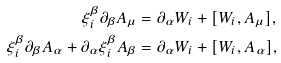Convert formula to latex. <formula><loc_0><loc_0><loc_500><loc_500>\xi _ { i } ^ { \beta } \partial _ { \beta } A _ { \mu } & = \partial _ { \alpha } W _ { i } + [ W _ { i } , A _ { \mu } ] , \\ \xi _ { i } ^ { \beta } \partial _ { \beta } A _ { \alpha } + \partial _ { \alpha } \xi _ { i } ^ { \beta } A _ { \beta } & = \partial _ { \alpha } W _ { i } + [ W _ { i } , A _ { \alpha } ] ,</formula> 